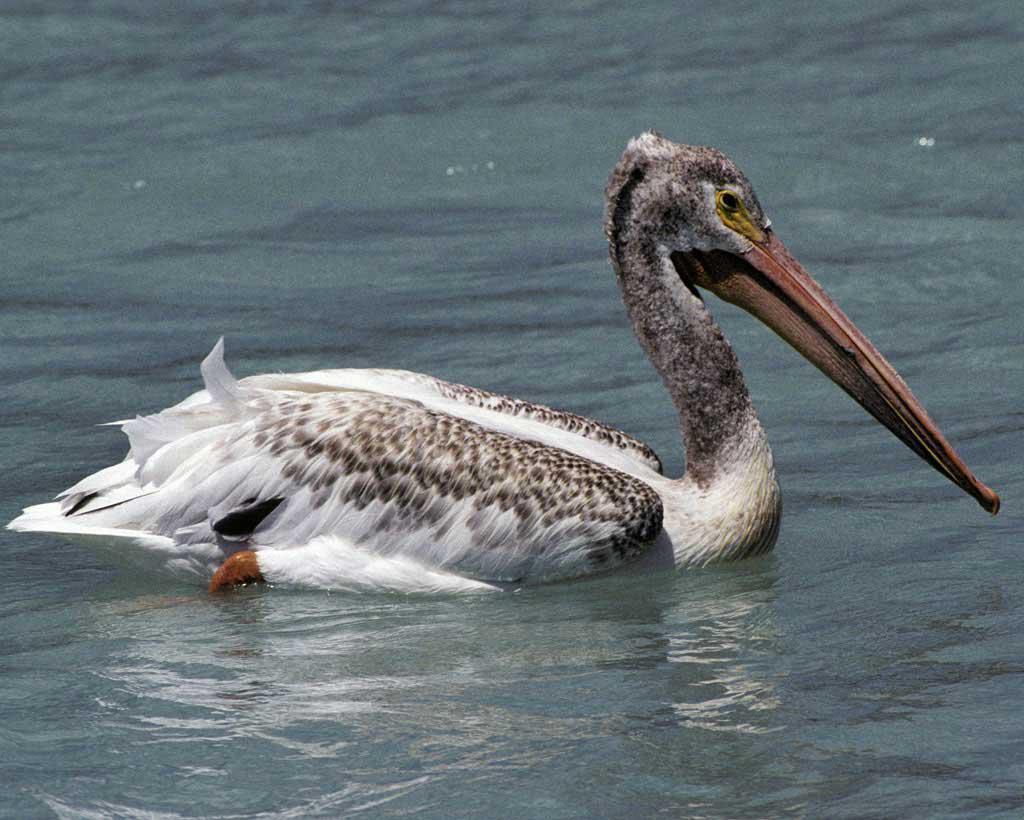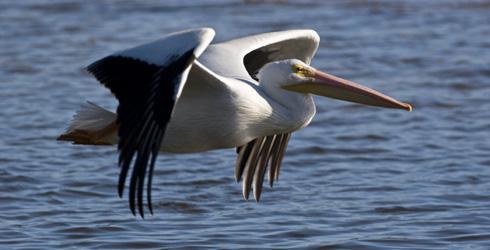The first image is the image on the left, the second image is the image on the right. For the images shown, is this caption "One image shows exactly one pelican on water facing right, and the other image shows a pelican flying above water." true? Answer yes or no. Yes. 